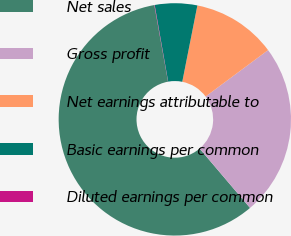<chart> <loc_0><loc_0><loc_500><loc_500><pie_chart><fcel>Net sales<fcel>Gross profit<fcel>Net earnings attributable to<fcel>Basic earnings per common<fcel>Diluted earnings per common<nl><fcel>58.38%<fcel>23.96%<fcel>11.72%<fcel>5.89%<fcel>0.05%<nl></chart> 